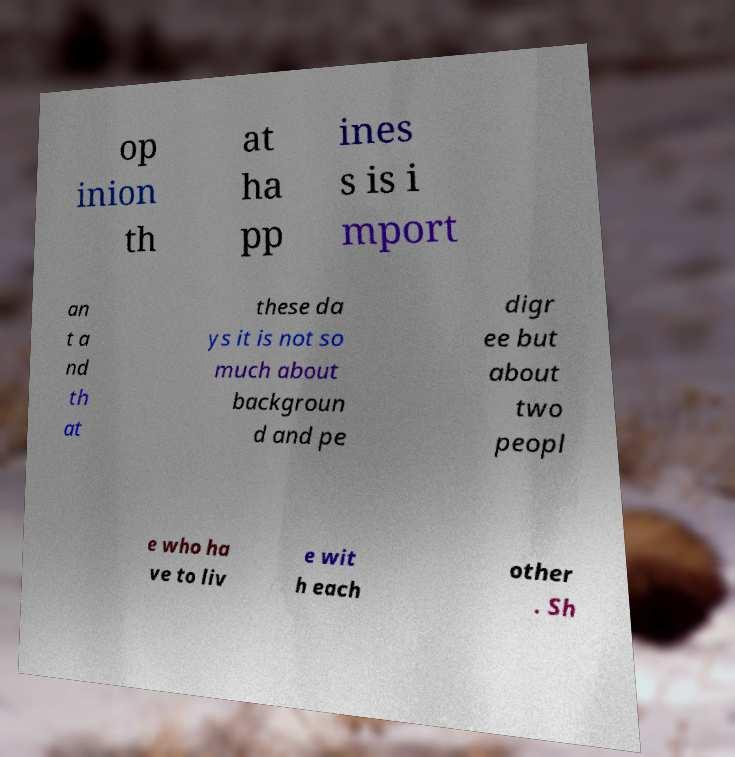Please identify and transcribe the text found in this image. op inion th at ha pp ines s is i mport an t a nd th at these da ys it is not so much about backgroun d and pe digr ee but about two peopl e who ha ve to liv e wit h each other . Sh 